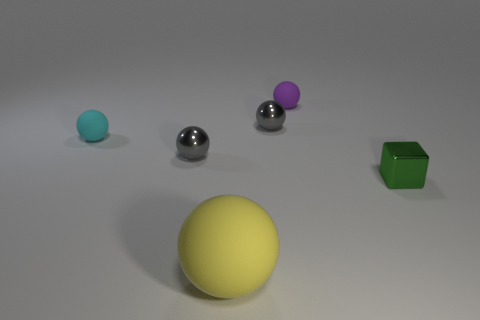Subtract all tiny purple spheres. How many spheres are left? 4 Subtract 1 spheres. How many spheres are left? 4 Subtract all yellow spheres. How many spheres are left? 4 Subtract all red balls. Subtract all yellow blocks. How many balls are left? 5 Add 3 large yellow things. How many objects exist? 9 Subtract all blocks. How many objects are left? 5 Subtract 0 green balls. How many objects are left? 6 Subtract all matte spheres. Subtract all tiny red metal objects. How many objects are left? 3 Add 6 matte balls. How many matte balls are left? 9 Add 2 large purple metal objects. How many large purple metal objects exist? 2 